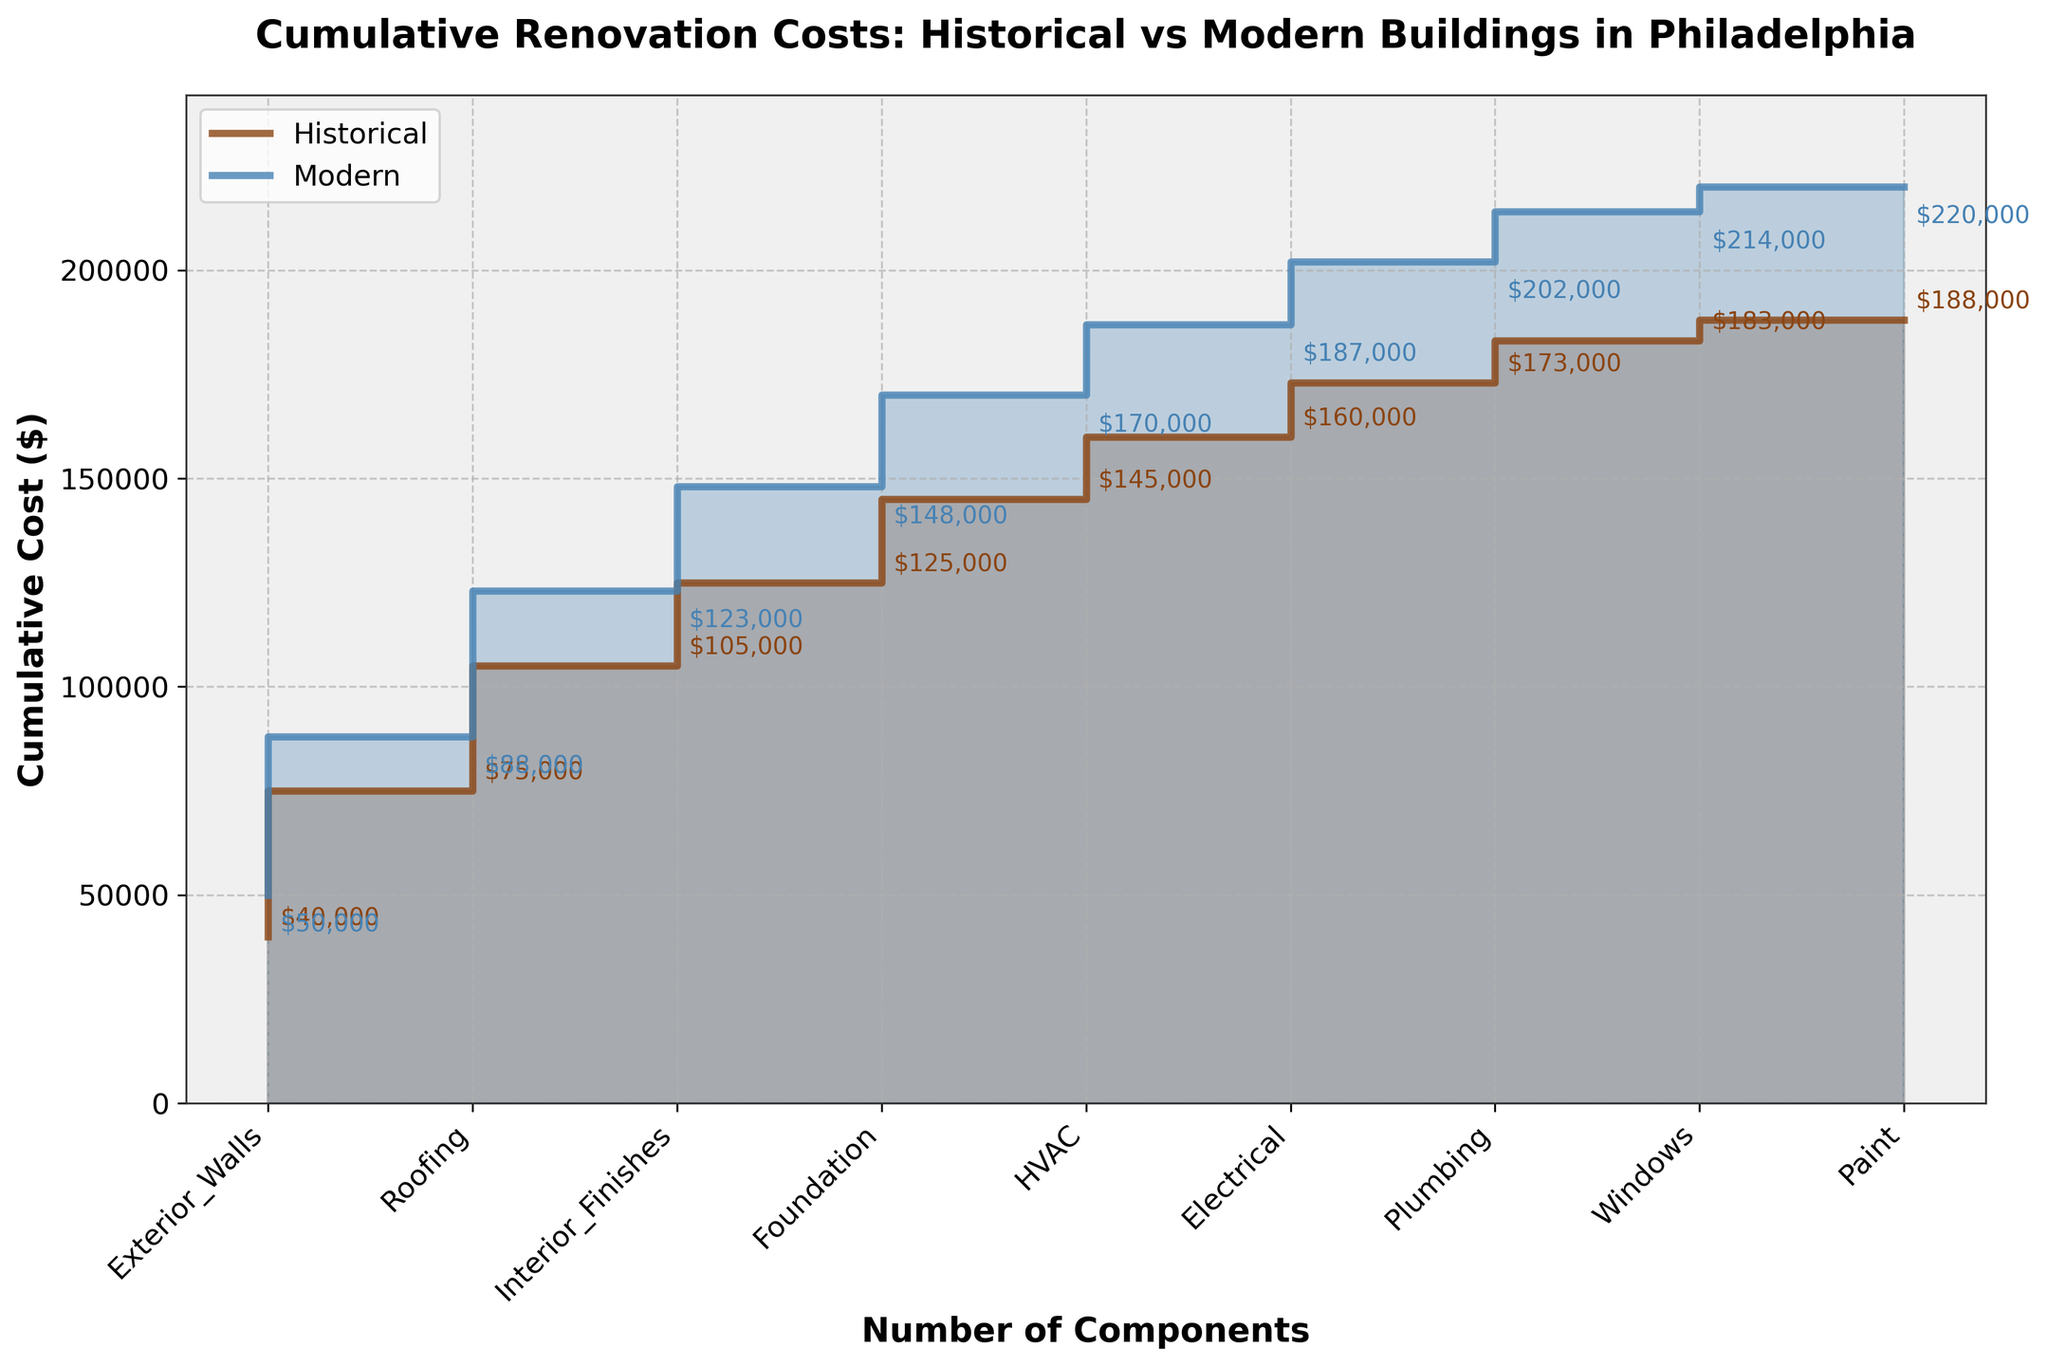What is the title of the plot? The title is written at the top center of the plot. It reads "Cumulative Renovation Costs: Historical vs Modern Buildings in Philadelphia".
Answer: Cumulative Renovation Costs: Historical vs Modern Buildings in Philadelphia How is the cost depicted for historical buildings versus modern buildings? The costs for historical buildings are shown with a brown line and shaded area, while the costs for modern buildings are represented with a blue line and shaded area.
Answer: Brown line for historical, blue line for modern Which component has the highest renovation cost for both building types? The x-axis labels the components and the cumulative cost steps reflect the costs. The component with the highest starting step is "Exterior Walls" for both building types based on cumulative height at that step.
Answer: Exterior Walls What is the cumulative cost for modern buildings after the first three most expensive components? For modern buildings, the first three components based on x-axis and sorting are "Exterior_Walls", "Roofing", and "Interior_Finishes", and their costs accumulate respectively to $50,000, $88,000, and $123,000.
Answer: $123,000 By how much do the cumulative costs differ between historical and modern buildings after the "Foundation" component? The cost after "Foundation" for historical buildings is $20,000 and for modern buildings is $25,000. The difference is $25,000 - $20,000.
Answer: $5,000 Which building type has higher cumulative costs for the "Windows" component? At the step marked "Windows", the cumulative cost for historical buildings is $105,000 and for modern buildings is $143,000.
Answer: Modern What is the total cumulative cost for historical buildings? The last cumulative step for historical buildings shows a total of $188,000.
Answer: $188,000 Compare the cost difference for "HVAC" and "Electrical" components between historical and modern buildings. The cost for "HVAC" is $20,000 for historical and $22,000 for modern, and for "Electrical" it is $15,000 for historical and $17,000 for modern, making the differences $2,000 for both components.
Answer: $2,000 each After how many components do the cumulative renovation costs for historical buildings exceed $100,000? The cumulative cost for historical buildings exceeds $100,000 after the 4th component, as seen in the stepped cost increases.
Answer: 4 components 